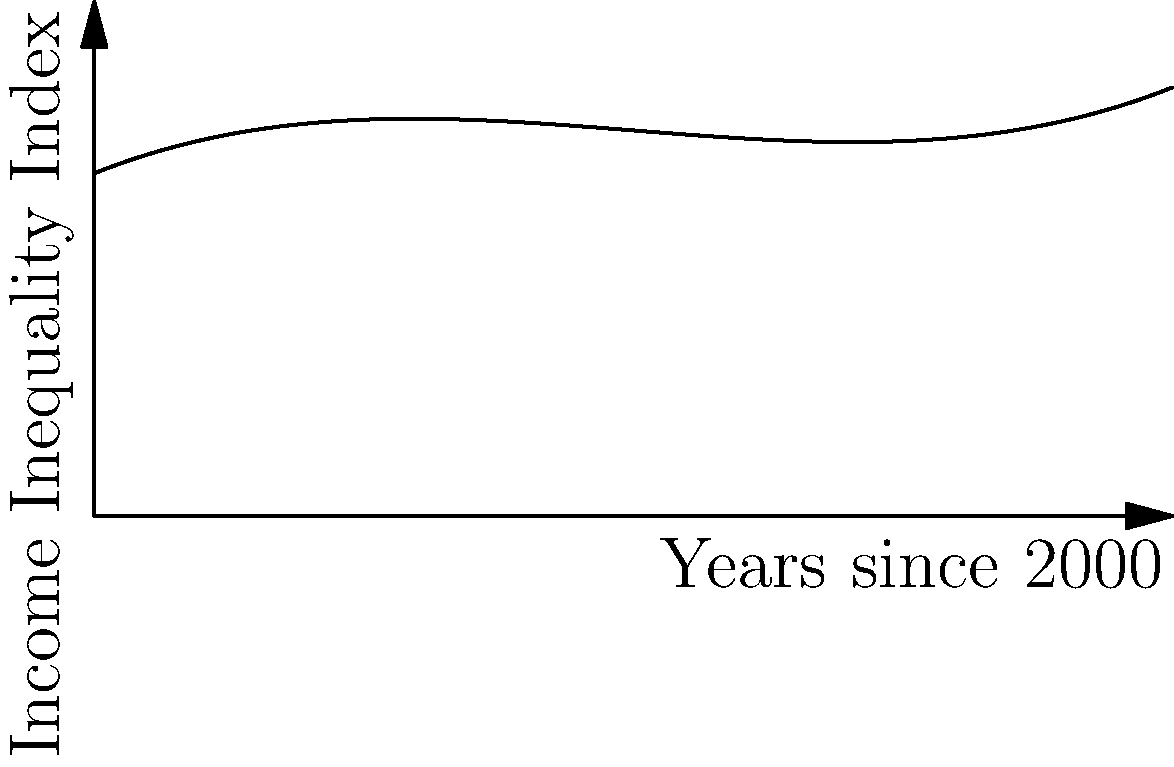As a social worker using films to educate youth about income inequality, you've created a polynomial model to represent the Income Inequality Index over time. The graph shows this model from the year 2000 to 2020. If the trend continues, what does this model suggest about income inequality in the future, and how might you use this information in your educational films? To analyze this polynomial graph and its implications for income inequality:

1. Observe the overall trend: The curve starts relatively flat, then increases more rapidly.

2. Identify key points:
   Point A (around 2005): Slight increase from the starting point
   Point B (around 2010): Steeper increase
   Point C (around 2015): Even steeper increase

3. Analyze the rate of change:
   The curve is becoming steeper over time, indicating an accelerating rate of increase in income inequality.

4. Extrapolate the trend:
   If this trend continues, income inequality will increase at an even faster rate in the future.

5. Implications for educational films:
   - Highlight the accelerating nature of income inequality
   - Discuss potential societal impacts of rapidly increasing inequality
   - Explore possible interventions to address this trend
   - Use the graph to visually demonstrate the urgency of addressing income inequality

6. Mathematical interpretation:
   The polynomial appears to be of degree 3 (cubic), which explains the accelerating growth rate. This suggests that without intervention, the problem may become increasingly difficult to address over time.
Answer: Accelerating increase in income inequality; use in films to demonstrate urgency and discuss interventions. 